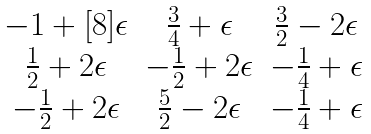Convert formula to latex. <formula><loc_0><loc_0><loc_500><loc_500>\begin{matrix} - 1 + [ 8 ] \epsilon & \frac { 3 } { 4 } + \epsilon & \frac { 3 } { 2 } - 2 \epsilon \\ \frac { 1 } { 2 } + 2 \epsilon & - \frac { 1 } { 2 } + 2 \epsilon & - \frac { 1 } { 4 } + \epsilon \\ - \frac { 1 } { 2 } + 2 \epsilon & \frac { 5 } { 2 } - 2 \epsilon & - \frac { 1 } { 4 } + \epsilon \end{matrix}</formula> 